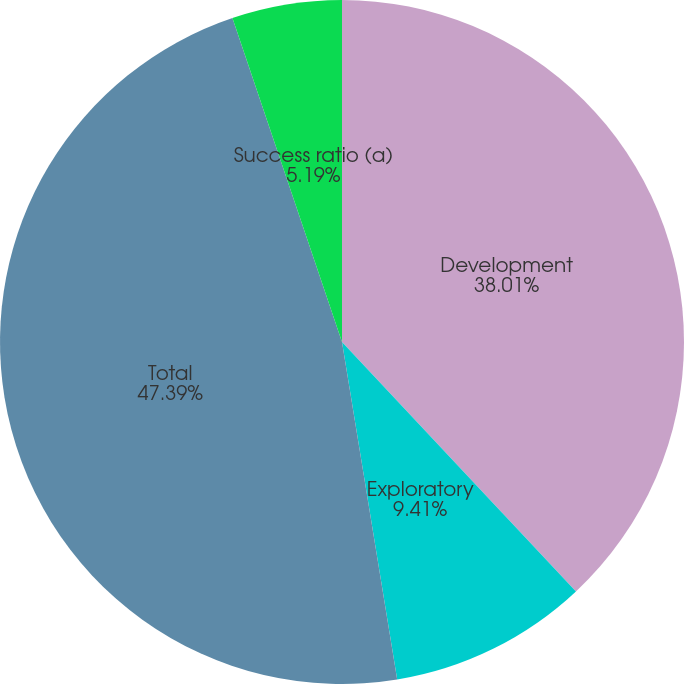Convert chart. <chart><loc_0><loc_0><loc_500><loc_500><pie_chart><fcel>Development<fcel>Exploratory<fcel>Total<fcel>Success ratio (a)<nl><fcel>38.01%<fcel>9.41%<fcel>47.39%<fcel>5.19%<nl></chart> 